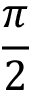<formula> <loc_0><loc_0><loc_500><loc_500>\frac { \pi } { 2 }</formula> 